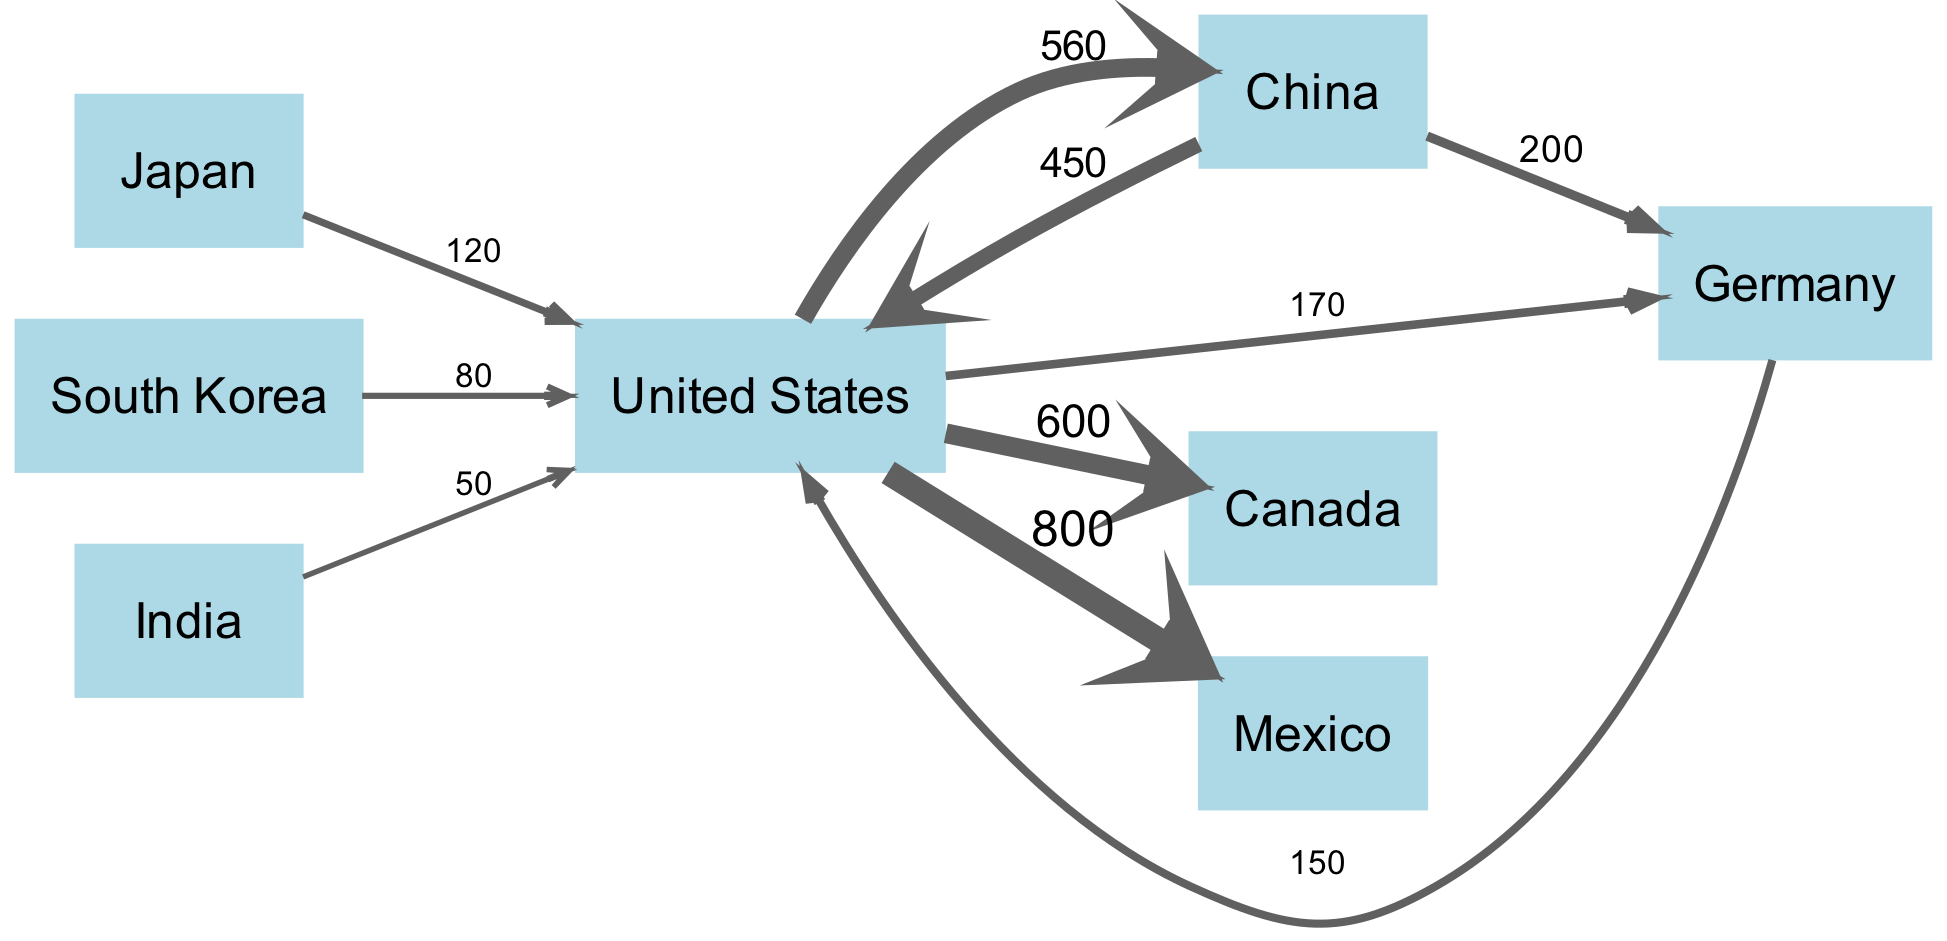What is the total export value from the United States to Mexico? The link between the United States and Mexico shows a value of 800, which indicates the total export amount from the United States to Mexico.
Answer: 800 Which country has the highest import value from the United States? The link from the United States to China is 560, which is the highest value among all imports for this country, indicating that China is the leading importer from the United States.
Answer: China How many countries are exporting to the United States? There are six distinct countries with outgoing links to the United States: China, Germany, Japan, South Korea, India, and Mexico. Thus, there are six countries exporting to the United States.
Answer: 6 What is the total flow of imports to the United States from all countries? Adding the values of all incoming links to the United States: 450 from China, 150 from Germany, 120 from Japan, 80 from South Korea, and 50 from India totals up to 850. Therefore, the total flow of imports to the United States is 850.
Answer: 850 Which country exports the least to the United States? The data shows that India has the smallest link value of 50, which makes it the country exporting the least to the United States.
Answer: India What is the combined export value from the United States to Canada and Mexico? The values from the United States to Canada is 600 and to Mexico is 800. Combining these gives a total export value of 600 + 800 = 1400.
Answer: 1400 What is the export value from China to Germany? The link from China to Germany displays a value of 200, indicating the total export amount from China to Germany.
Answer: 200 Which country exports more to the United States: Japan or South Korea? Japan exports to the United States with a value of 120, while South Korea exports with a value of 80. Since 120 is greater than 80, Japan exports more to the United States than South Korea does.
Answer: Japan How does Germany's export to the United States compare to China's export to the United States? The export from Germany to the United States is 150, while the export from China to the United States is 450. Since 450 is greater than 150, China exports more to the United States than Germany.
Answer: China 